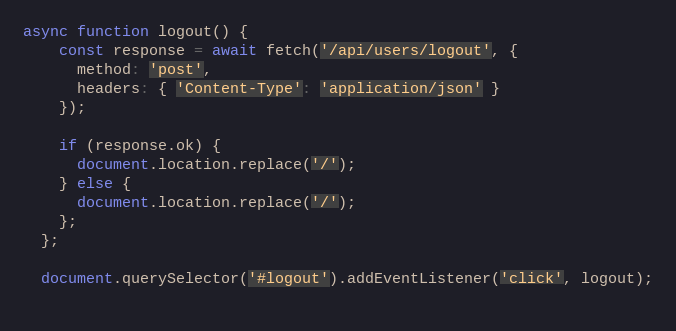<code> <loc_0><loc_0><loc_500><loc_500><_JavaScript_>async function logout() {
    const response = await fetch('/api/users/logout', {
      method: 'post',
      headers: { 'Content-Type': 'application/json' }
    });
  
    if (response.ok) {
      document.location.replace('/');
    } else {
      document.location.replace('/');
    };
  };
  
  document.querySelector('#logout').addEventListener('click', logout);
  </code> 